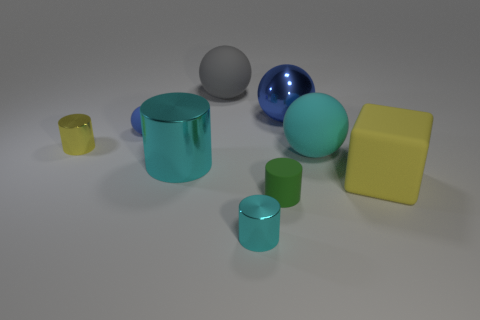Add 1 purple cylinders. How many objects exist? 10 Subtract all purple cylinders. Subtract all yellow blocks. How many cylinders are left? 4 Subtract all cubes. How many objects are left? 8 Add 6 cyan matte objects. How many cyan matte objects exist? 7 Subtract 1 cyan balls. How many objects are left? 8 Subtract all big yellow rubber things. Subtract all small rubber cylinders. How many objects are left? 7 Add 8 small cyan cylinders. How many small cyan cylinders are left? 9 